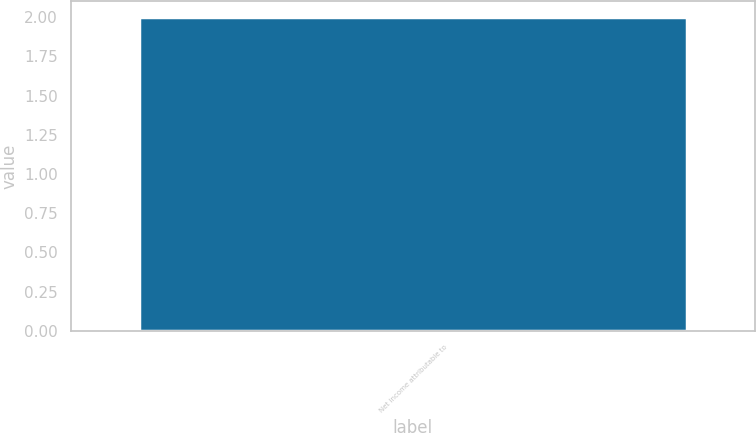<chart> <loc_0><loc_0><loc_500><loc_500><bar_chart><fcel>Net income attributable to<nl><fcel>2<nl></chart> 